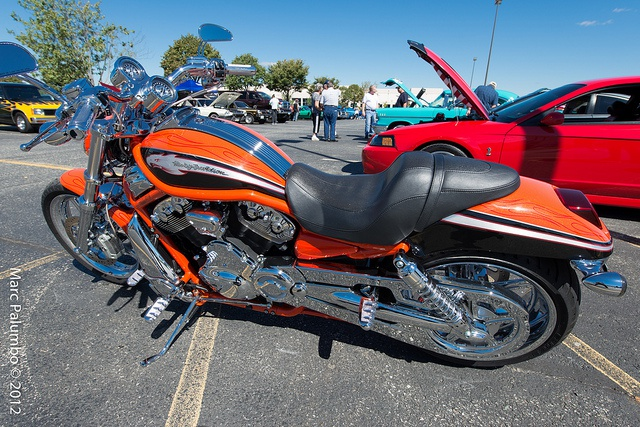Describe the objects in this image and their specific colors. I can see motorcycle in lightblue, black, gray, darkgray, and red tones, car in lightblue, red, black, maroon, and brown tones, car in lightblue, turquoise, cyan, white, and teal tones, car in lightblue, black, gold, gray, and navy tones, and car in lightblue, white, gray, black, and darkgray tones in this image. 